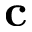Convert formula to latex. <formula><loc_0><loc_0><loc_500><loc_500>c</formula> 